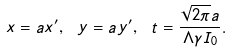Convert formula to latex. <formula><loc_0><loc_0><loc_500><loc_500>x = a x ^ { \prime } , \ y = a y ^ { \prime } , \ t = \frac { \sqrt { 2 \pi } a } { \Lambda \gamma I _ { 0 } } .</formula> 